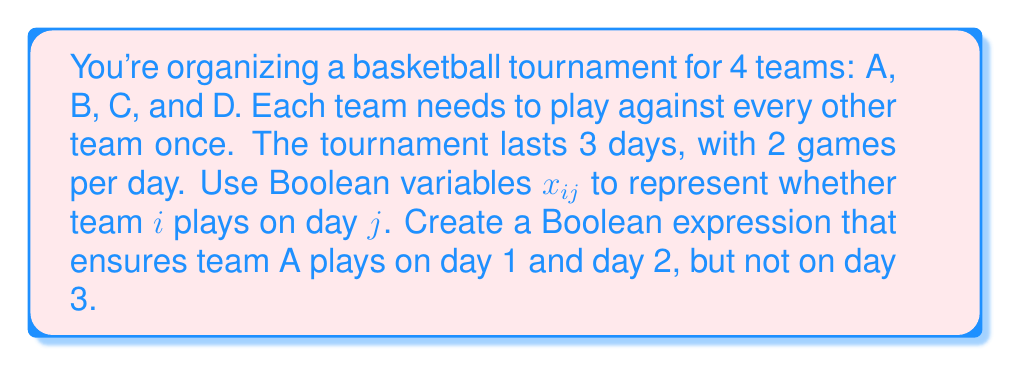Solve this math problem. Let's approach this step-by-step:

1) We define Boolean variables $x_{ij}$ where:
   $i \in \{A, B, C, D\}$ represents the team
   $j \in \{1, 2, 3\}$ represents the day

2) $x_{ij} = 1$ if team $i$ plays on day $j$, and 0 otherwise

3) For team A to play on day 1 and day 2, but not on day 3, we need:
   $x_{A1} = 1$
   $x_{A2} = 1$
   $x_{A3} = 0$

4) In Boolean algebra, we can represent this as:
   $x_{A1} \land x_{A2} \land \lnot x_{A3}$

5) This expression will be true (1) only when team A plays on days 1 and 2, but not on day 3.

6) We can also write this using product notation in Boolean algebra:
   $x_{A1} \cdot x_{A2} \cdot \overline{x_{A3}}$

Where $\cdot$ represents AND, and the bar over $x_{A3}$ represents NOT.
Answer: $x_{A1} \land x_{A2} \land \lnot x_{A3}$ 